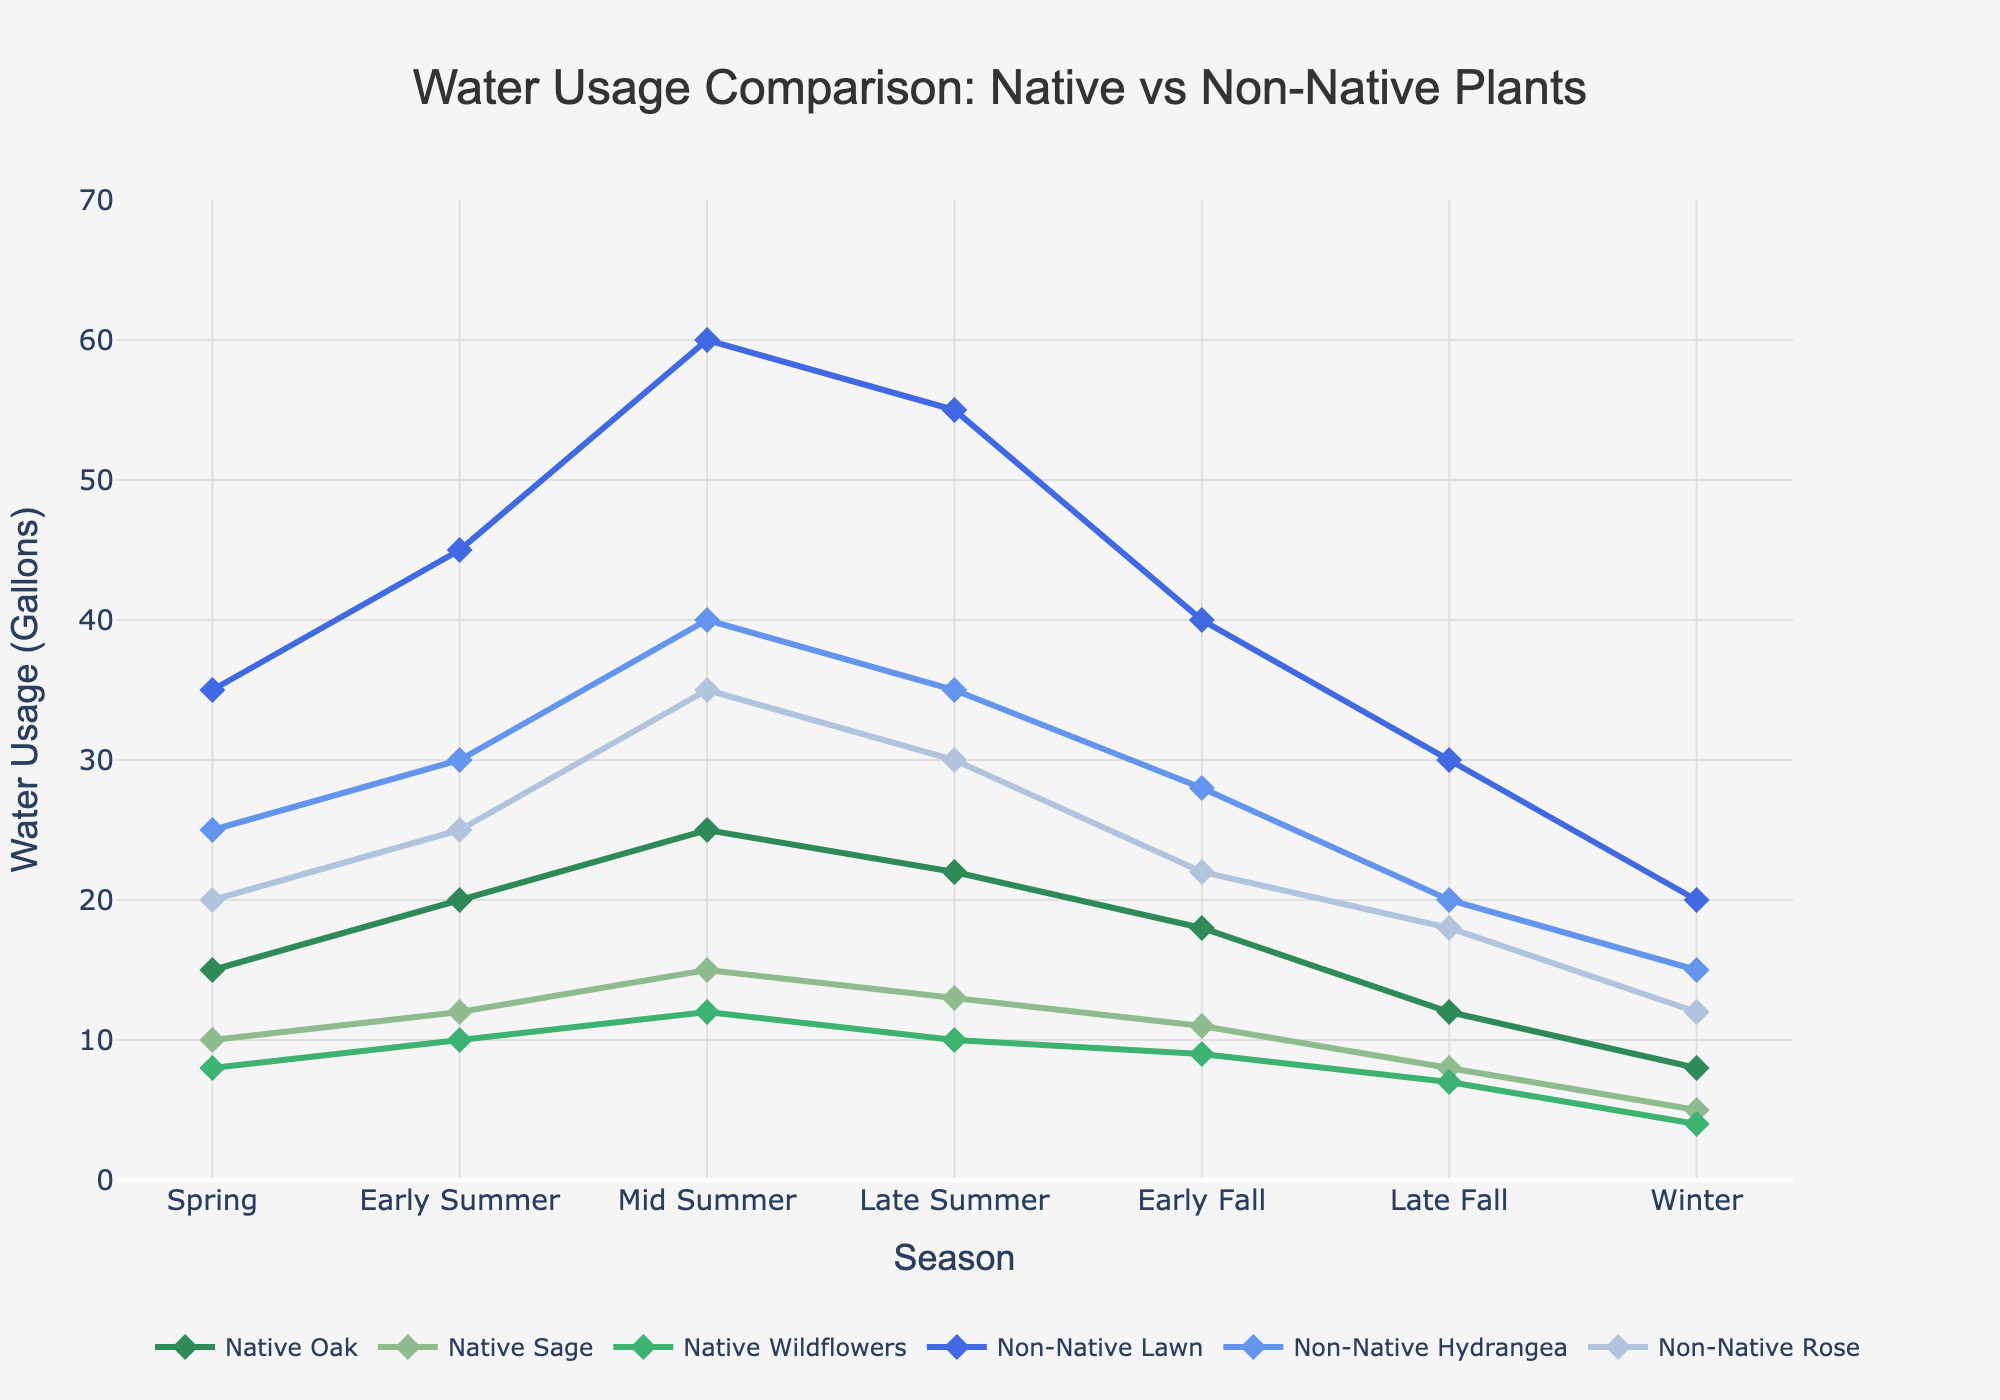Which plant type uses the most water in Mid Summer? From the plot, each line reaches its peak water usage in Mid Summer. The Non-Native Lawn reaches the highest point, indicating it uses the most water in Mid Summer.
Answer: Non-Native Lawn How does water usage of Native Sage change from Spring to Winter? The graph shows a decrease in water usage for Native Sage from Spring to Winter, starting at 10 gallons in Spring and decreasing gradually to 5 gallons in Winter.
Answer: Decreases What's the total water usage for Non-Native Rose across all seasons? We need to sum the water usage of Non-Native Rose across all seasons: 20 (Spring) + 25 (Early Summer) + 35 (Mid Summer) + 30 (Late Summer) + 22 (Early Fall) + 18 (Late Fall) + 12 (Winter) = 162 gallons.
Answer: 162 gallons Which native plant shows the least variation in water usage throughout the year? By observing the range between the highest and lowest points for each native plant, Native Wildflowers vary from 12 gallons at Mid Summer to 4 gallons in Winter, which is less compared to Native Oak and Native Sage.
Answer: Native Wildflowers During which season do both Native Oak and Non-Native Lawn have their peak water usage, and what are those values? The peak values for both Native Oak and Non-Native Lawn occur in Mid Summer, where Native Oak uses 25 gallons and Non-Native Lawn uses 60 gallons of water.
Answer: Mid Summer, 25 gallons (Native Oak), 60 gallons (Non-Native Lawn) Compare the water usage of Non-Native Hydrangea and Native Oak in Late Fall. In Late Fall, Non-Native Hydrangea uses 20 gallons of water, while Native Oak uses 12 gallons. Non-Native Hydrangea's line is higher than that of Native Oak.
Answer: Non-Native Hydrangea uses more What's the average water usage of Native Sage in the seasons other than Summer? Calculate the average water usage of Native Sage in Spring, Early Fall, Late Fall, and Winter: (10 + 11 + 8 + 5)/4 = 8.5 gallons.
Answer: 8.5 gallons What is the difference in peak water usage between Non-Native Lawn and Non-Native Rose? The peak usage for Non-Native Lawn is 60 gallons in Mid Summer, and for Non-Native Rose, it's 35 gallons also in Mid Summer. The difference is 60 - 35 = 25 gallons.
Answer: 25 gallons Which season shows the highest total water usage for all plants combined? Sum the water usage for all plants in each season and compare. For Mid Summer: (25 + 15 + 12 + 60 + 40 + 35) = 187 gallons, which is the highest among all seasons.
Answer: Mid Summer How does the water usage trend for Non-Native Hydrangea change from Early Summer to Winter? From the plot, Non-Native Hydrangea's water usage increases from Early Summer (30 gallons) to Mid Summer (40 gallons), then decreases through Late Summer (35 gallons), Early Fall (28 gallons), Late Fall (20 gallons), and Winter (15 gallons).
Answer: Increases then decreases 